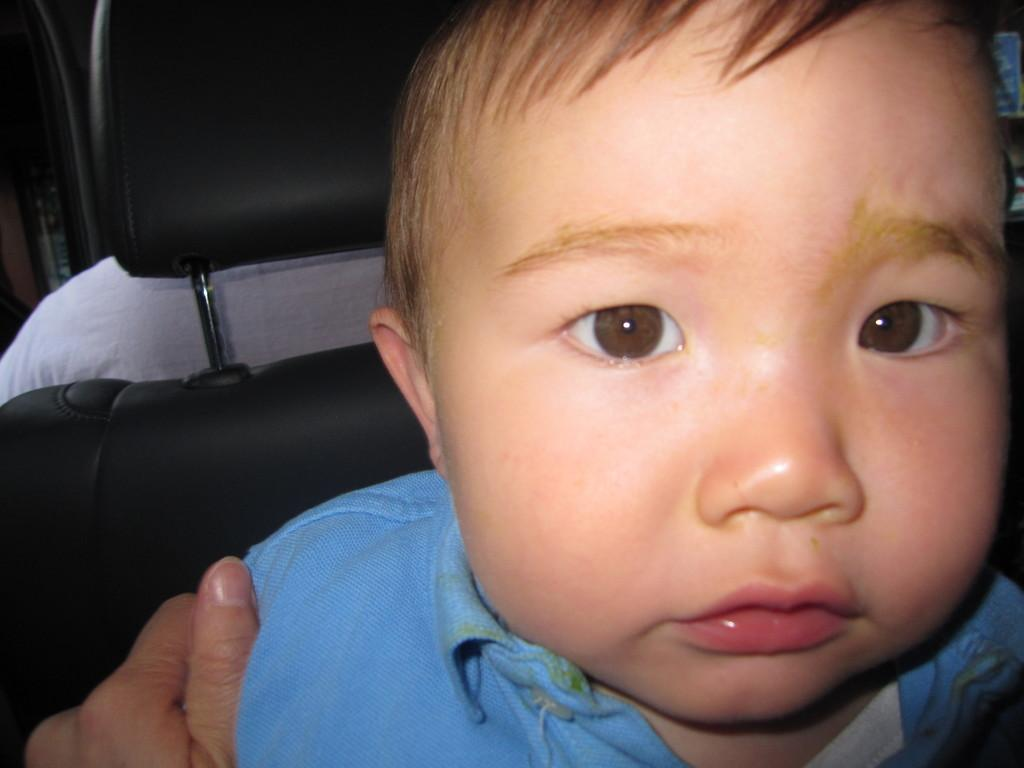Who is the main subject in the image? The main subject in the image is a boy. What is the boy wearing? The boy is wearing a blue shirt. Is there anyone else in the image besides the boy? Yes, a person is holding the boy. What can be seen in the background of the image? There is a chair in the image. Who is sitting in the chair? A person is sitting in the chair. What type of yam is being discussed by the person sitting in the chair? There is no yam present in the image, nor is there any discussion about yams. 